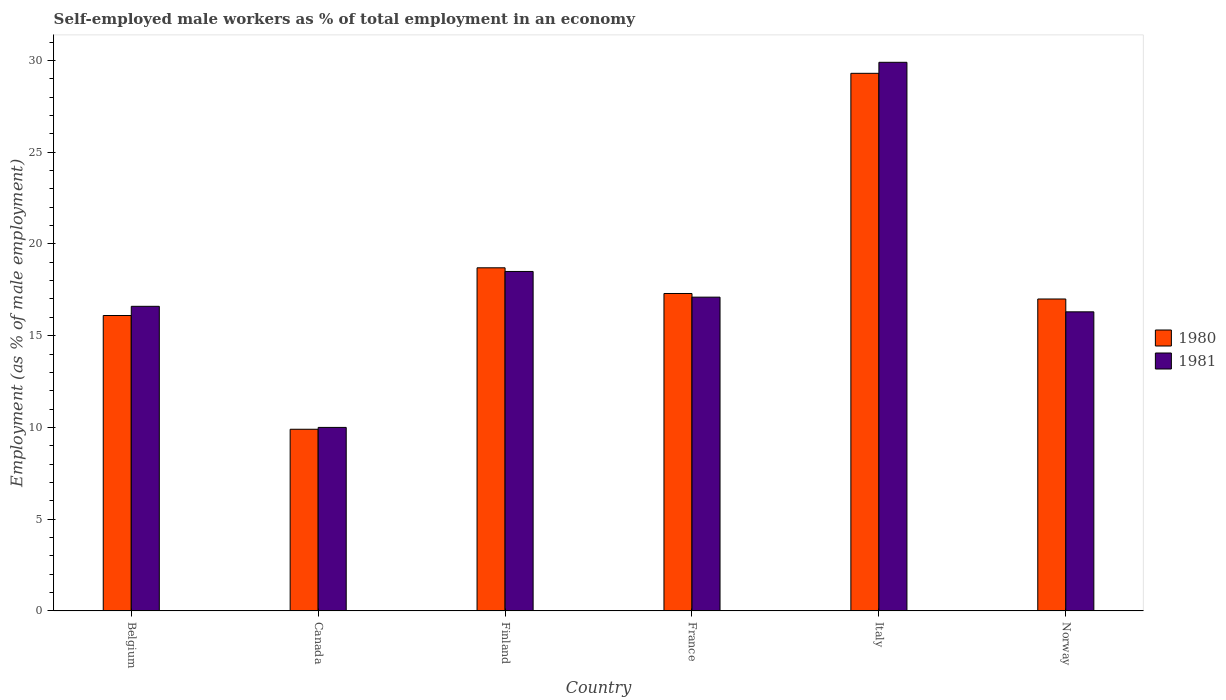How many different coloured bars are there?
Provide a succinct answer. 2. Are the number of bars per tick equal to the number of legend labels?
Your answer should be very brief. Yes. Are the number of bars on each tick of the X-axis equal?
Give a very brief answer. Yes. How many bars are there on the 2nd tick from the left?
Keep it short and to the point. 2. How many bars are there on the 2nd tick from the right?
Offer a very short reply. 2. What is the label of the 3rd group of bars from the left?
Offer a terse response. Finland. In how many cases, is the number of bars for a given country not equal to the number of legend labels?
Offer a very short reply. 0. Across all countries, what is the maximum percentage of self-employed male workers in 1981?
Offer a terse response. 29.9. Across all countries, what is the minimum percentage of self-employed male workers in 1980?
Your answer should be compact. 9.9. In which country was the percentage of self-employed male workers in 1980 maximum?
Your answer should be compact. Italy. What is the total percentage of self-employed male workers in 1980 in the graph?
Offer a very short reply. 108.3. What is the difference between the percentage of self-employed male workers in 1980 in Belgium and that in France?
Provide a succinct answer. -1.2. What is the difference between the percentage of self-employed male workers in 1981 in Norway and the percentage of self-employed male workers in 1980 in Finland?
Your answer should be very brief. -2.4. What is the average percentage of self-employed male workers in 1980 per country?
Provide a short and direct response. 18.05. What is the difference between the percentage of self-employed male workers of/in 1980 and percentage of self-employed male workers of/in 1981 in Finland?
Your response must be concise. 0.2. What is the ratio of the percentage of self-employed male workers in 1981 in Italy to that in Norway?
Make the answer very short. 1.83. Is the difference between the percentage of self-employed male workers in 1980 in Canada and Italy greater than the difference between the percentage of self-employed male workers in 1981 in Canada and Italy?
Provide a succinct answer. Yes. What is the difference between the highest and the second highest percentage of self-employed male workers in 1981?
Give a very brief answer. -1.4. What is the difference between the highest and the lowest percentage of self-employed male workers in 1981?
Offer a very short reply. 19.9. Are all the bars in the graph horizontal?
Keep it short and to the point. No. How many countries are there in the graph?
Offer a terse response. 6. Are the values on the major ticks of Y-axis written in scientific E-notation?
Offer a very short reply. No. Does the graph contain any zero values?
Provide a short and direct response. No. How are the legend labels stacked?
Provide a succinct answer. Vertical. What is the title of the graph?
Provide a short and direct response. Self-employed male workers as % of total employment in an economy. What is the label or title of the Y-axis?
Provide a succinct answer. Employment (as % of male employment). What is the Employment (as % of male employment) in 1980 in Belgium?
Give a very brief answer. 16.1. What is the Employment (as % of male employment) in 1981 in Belgium?
Ensure brevity in your answer.  16.6. What is the Employment (as % of male employment) of 1980 in Canada?
Offer a terse response. 9.9. What is the Employment (as % of male employment) in 1980 in Finland?
Provide a succinct answer. 18.7. What is the Employment (as % of male employment) in 1980 in France?
Provide a succinct answer. 17.3. What is the Employment (as % of male employment) in 1981 in France?
Ensure brevity in your answer.  17.1. What is the Employment (as % of male employment) in 1980 in Italy?
Your response must be concise. 29.3. What is the Employment (as % of male employment) in 1981 in Italy?
Offer a very short reply. 29.9. What is the Employment (as % of male employment) of 1980 in Norway?
Provide a succinct answer. 17. What is the Employment (as % of male employment) in 1981 in Norway?
Provide a succinct answer. 16.3. Across all countries, what is the maximum Employment (as % of male employment) in 1980?
Your response must be concise. 29.3. Across all countries, what is the maximum Employment (as % of male employment) in 1981?
Your response must be concise. 29.9. Across all countries, what is the minimum Employment (as % of male employment) in 1980?
Your answer should be very brief. 9.9. What is the total Employment (as % of male employment) in 1980 in the graph?
Provide a succinct answer. 108.3. What is the total Employment (as % of male employment) in 1981 in the graph?
Your answer should be compact. 108.4. What is the difference between the Employment (as % of male employment) of 1980 in Belgium and that in Canada?
Keep it short and to the point. 6.2. What is the difference between the Employment (as % of male employment) of 1981 in Belgium and that in Canada?
Ensure brevity in your answer.  6.6. What is the difference between the Employment (as % of male employment) in 1981 in Belgium and that in France?
Keep it short and to the point. -0.5. What is the difference between the Employment (as % of male employment) in 1980 in Belgium and that in Italy?
Offer a very short reply. -13.2. What is the difference between the Employment (as % of male employment) in 1980 in Canada and that in Finland?
Keep it short and to the point. -8.8. What is the difference between the Employment (as % of male employment) in 1980 in Canada and that in France?
Offer a terse response. -7.4. What is the difference between the Employment (as % of male employment) in 1980 in Canada and that in Italy?
Make the answer very short. -19.4. What is the difference between the Employment (as % of male employment) in 1981 in Canada and that in Italy?
Your answer should be compact. -19.9. What is the difference between the Employment (as % of male employment) in 1980 in Canada and that in Norway?
Your answer should be very brief. -7.1. What is the difference between the Employment (as % of male employment) in 1981 in Canada and that in Norway?
Provide a short and direct response. -6.3. What is the difference between the Employment (as % of male employment) of 1981 in Finland and that in France?
Your answer should be compact. 1.4. What is the difference between the Employment (as % of male employment) in 1981 in Finland and that in Italy?
Offer a very short reply. -11.4. What is the difference between the Employment (as % of male employment) in 1980 in Finland and that in Norway?
Keep it short and to the point. 1.7. What is the difference between the Employment (as % of male employment) in 1981 in Finland and that in Norway?
Your answer should be very brief. 2.2. What is the difference between the Employment (as % of male employment) of 1981 in France and that in Italy?
Make the answer very short. -12.8. What is the difference between the Employment (as % of male employment) of 1980 in France and that in Norway?
Provide a short and direct response. 0.3. What is the difference between the Employment (as % of male employment) in 1980 in Belgium and the Employment (as % of male employment) in 1981 in Canada?
Provide a succinct answer. 6.1. What is the difference between the Employment (as % of male employment) in 1980 in Canada and the Employment (as % of male employment) in 1981 in Finland?
Your response must be concise. -8.6. What is the difference between the Employment (as % of male employment) in 1980 in Canada and the Employment (as % of male employment) in 1981 in Norway?
Your response must be concise. -6.4. What is the difference between the Employment (as % of male employment) of 1980 in Finland and the Employment (as % of male employment) of 1981 in Norway?
Your answer should be compact. 2.4. What is the difference between the Employment (as % of male employment) in 1980 in France and the Employment (as % of male employment) in 1981 in Italy?
Ensure brevity in your answer.  -12.6. What is the difference between the Employment (as % of male employment) of 1980 in France and the Employment (as % of male employment) of 1981 in Norway?
Provide a succinct answer. 1. What is the difference between the Employment (as % of male employment) of 1980 in Italy and the Employment (as % of male employment) of 1981 in Norway?
Provide a succinct answer. 13. What is the average Employment (as % of male employment) in 1980 per country?
Provide a short and direct response. 18.05. What is the average Employment (as % of male employment) of 1981 per country?
Offer a terse response. 18.07. What is the difference between the Employment (as % of male employment) in 1980 and Employment (as % of male employment) in 1981 in Belgium?
Offer a terse response. -0.5. What is the difference between the Employment (as % of male employment) in 1980 and Employment (as % of male employment) in 1981 in Canada?
Your response must be concise. -0.1. What is the difference between the Employment (as % of male employment) of 1980 and Employment (as % of male employment) of 1981 in Finland?
Your answer should be very brief. 0.2. What is the difference between the Employment (as % of male employment) in 1980 and Employment (as % of male employment) in 1981 in France?
Your answer should be compact. 0.2. What is the difference between the Employment (as % of male employment) in 1980 and Employment (as % of male employment) in 1981 in Italy?
Your answer should be compact. -0.6. What is the difference between the Employment (as % of male employment) of 1980 and Employment (as % of male employment) of 1981 in Norway?
Provide a short and direct response. 0.7. What is the ratio of the Employment (as % of male employment) in 1980 in Belgium to that in Canada?
Make the answer very short. 1.63. What is the ratio of the Employment (as % of male employment) of 1981 in Belgium to that in Canada?
Provide a short and direct response. 1.66. What is the ratio of the Employment (as % of male employment) of 1980 in Belgium to that in Finland?
Your answer should be compact. 0.86. What is the ratio of the Employment (as % of male employment) of 1981 in Belgium to that in Finland?
Your answer should be compact. 0.9. What is the ratio of the Employment (as % of male employment) of 1980 in Belgium to that in France?
Your answer should be compact. 0.93. What is the ratio of the Employment (as % of male employment) of 1981 in Belgium to that in France?
Your answer should be compact. 0.97. What is the ratio of the Employment (as % of male employment) in 1980 in Belgium to that in Italy?
Offer a very short reply. 0.55. What is the ratio of the Employment (as % of male employment) of 1981 in Belgium to that in Italy?
Your answer should be compact. 0.56. What is the ratio of the Employment (as % of male employment) in 1980 in Belgium to that in Norway?
Your response must be concise. 0.95. What is the ratio of the Employment (as % of male employment) in 1981 in Belgium to that in Norway?
Your answer should be very brief. 1.02. What is the ratio of the Employment (as % of male employment) in 1980 in Canada to that in Finland?
Your answer should be compact. 0.53. What is the ratio of the Employment (as % of male employment) in 1981 in Canada to that in Finland?
Your answer should be compact. 0.54. What is the ratio of the Employment (as % of male employment) of 1980 in Canada to that in France?
Your response must be concise. 0.57. What is the ratio of the Employment (as % of male employment) of 1981 in Canada to that in France?
Your response must be concise. 0.58. What is the ratio of the Employment (as % of male employment) of 1980 in Canada to that in Italy?
Provide a succinct answer. 0.34. What is the ratio of the Employment (as % of male employment) in 1981 in Canada to that in Italy?
Make the answer very short. 0.33. What is the ratio of the Employment (as % of male employment) in 1980 in Canada to that in Norway?
Your response must be concise. 0.58. What is the ratio of the Employment (as % of male employment) in 1981 in Canada to that in Norway?
Offer a very short reply. 0.61. What is the ratio of the Employment (as % of male employment) in 1980 in Finland to that in France?
Ensure brevity in your answer.  1.08. What is the ratio of the Employment (as % of male employment) of 1981 in Finland to that in France?
Your answer should be compact. 1.08. What is the ratio of the Employment (as % of male employment) of 1980 in Finland to that in Italy?
Make the answer very short. 0.64. What is the ratio of the Employment (as % of male employment) in 1981 in Finland to that in Italy?
Keep it short and to the point. 0.62. What is the ratio of the Employment (as % of male employment) of 1980 in Finland to that in Norway?
Give a very brief answer. 1.1. What is the ratio of the Employment (as % of male employment) in 1981 in Finland to that in Norway?
Keep it short and to the point. 1.14. What is the ratio of the Employment (as % of male employment) of 1980 in France to that in Italy?
Provide a succinct answer. 0.59. What is the ratio of the Employment (as % of male employment) in 1981 in France to that in Italy?
Offer a terse response. 0.57. What is the ratio of the Employment (as % of male employment) of 1980 in France to that in Norway?
Offer a terse response. 1.02. What is the ratio of the Employment (as % of male employment) of 1981 in France to that in Norway?
Your response must be concise. 1.05. What is the ratio of the Employment (as % of male employment) of 1980 in Italy to that in Norway?
Offer a terse response. 1.72. What is the ratio of the Employment (as % of male employment) in 1981 in Italy to that in Norway?
Your response must be concise. 1.83. What is the difference between the highest and the second highest Employment (as % of male employment) in 1980?
Give a very brief answer. 10.6. What is the difference between the highest and the lowest Employment (as % of male employment) in 1980?
Keep it short and to the point. 19.4. 